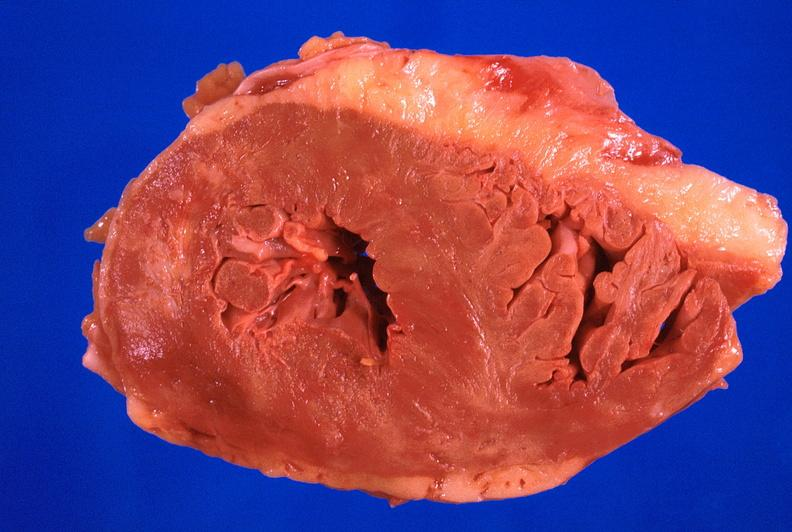what is present?
Answer the question using a single word or phrase. Cardiovascular 